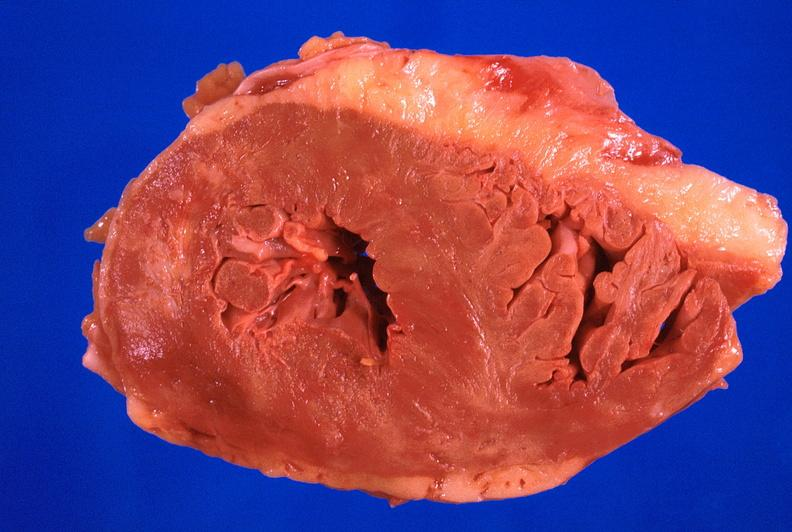what is present?
Answer the question using a single word or phrase. Cardiovascular 